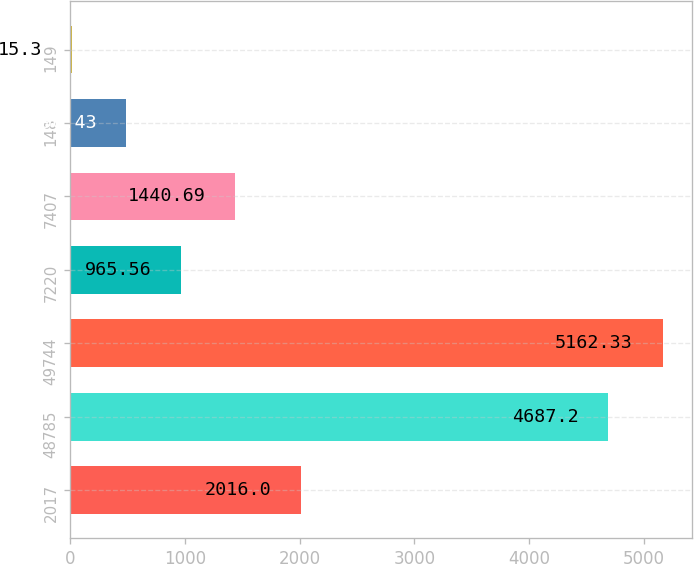Convert chart. <chart><loc_0><loc_0><loc_500><loc_500><bar_chart><fcel>2017<fcel>48785<fcel>49744<fcel>7220<fcel>7407<fcel>148<fcel>149<nl><fcel>2016<fcel>4687.2<fcel>5162.33<fcel>965.56<fcel>1440.69<fcel>490.43<fcel>15.3<nl></chart> 